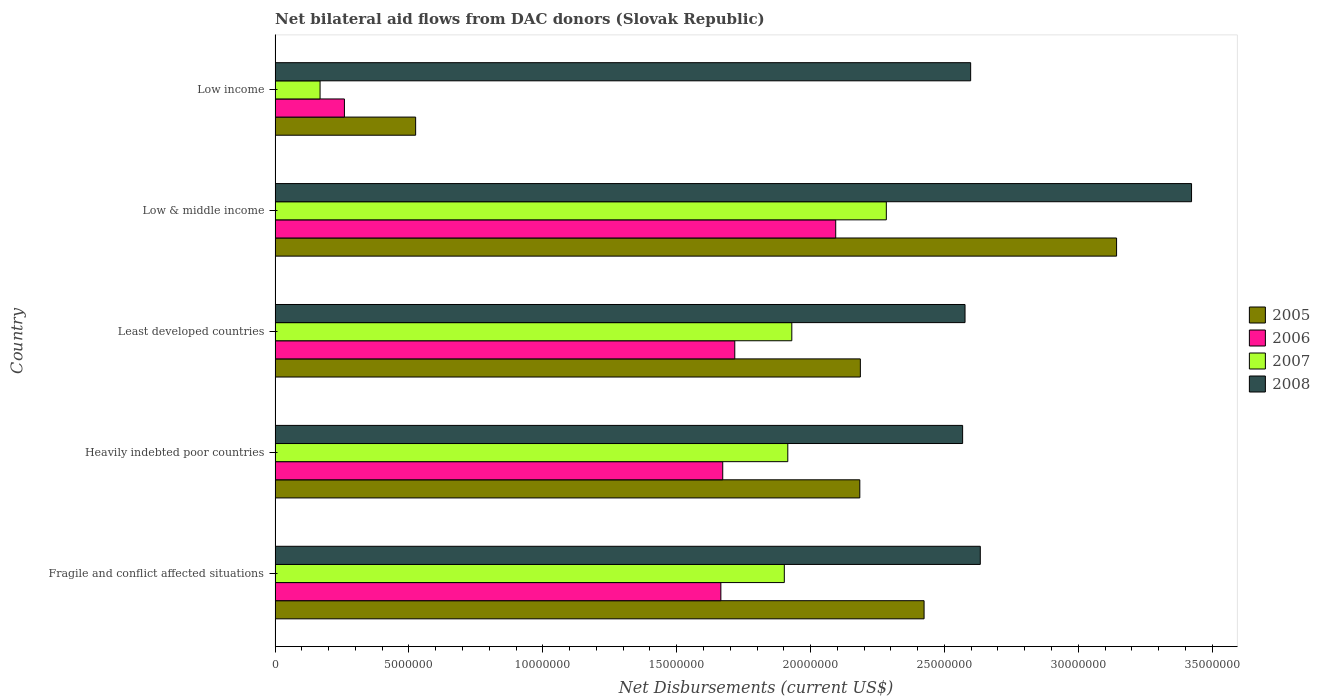How many different coloured bars are there?
Your answer should be very brief. 4. How many groups of bars are there?
Ensure brevity in your answer.  5. How many bars are there on the 3rd tick from the top?
Give a very brief answer. 4. What is the label of the 4th group of bars from the top?
Make the answer very short. Heavily indebted poor countries. What is the net bilateral aid flows in 2008 in Fragile and conflict affected situations?
Your answer should be very brief. 2.63e+07. Across all countries, what is the maximum net bilateral aid flows in 2005?
Give a very brief answer. 3.14e+07. Across all countries, what is the minimum net bilateral aid flows in 2006?
Give a very brief answer. 2.59e+06. In which country was the net bilateral aid flows in 2008 minimum?
Give a very brief answer. Heavily indebted poor countries. What is the total net bilateral aid flows in 2006 in the graph?
Offer a very short reply. 7.41e+07. What is the difference between the net bilateral aid flows in 2005 in Low & middle income and that in Low income?
Give a very brief answer. 2.62e+07. What is the difference between the net bilateral aid flows in 2006 in Low income and the net bilateral aid flows in 2005 in Low & middle income?
Offer a terse response. -2.88e+07. What is the average net bilateral aid flows in 2008 per country?
Provide a short and direct response. 2.76e+07. What is the difference between the net bilateral aid flows in 2007 and net bilateral aid flows in 2006 in Heavily indebted poor countries?
Offer a terse response. 2.43e+06. In how many countries, is the net bilateral aid flows in 2007 greater than 29000000 US$?
Provide a succinct answer. 0. What is the ratio of the net bilateral aid flows in 2005 in Fragile and conflict affected situations to that in Least developed countries?
Your answer should be very brief. 1.11. Is the difference between the net bilateral aid flows in 2007 in Fragile and conflict affected situations and Low income greater than the difference between the net bilateral aid flows in 2006 in Fragile and conflict affected situations and Low income?
Your answer should be very brief. Yes. What is the difference between the highest and the second highest net bilateral aid flows in 2008?
Ensure brevity in your answer.  7.89e+06. What is the difference between the highest and the lowest net bilateral aid flows in 2006?
Provide a short and direct response. 1.84e+07. In how many countries, is the net bilateral aid flows in 2005 greater than the average net bilateral aid flows in 2005 taken over all countries?
Keep it short and to the point. 4. Is the sum of the net bilateral aid flows in 2007 in Heavily indebted poor countries and Least developed countries greater than the maximum net bilateral aid flows in 2005 across all countries?
Your response must be concise. Yes. Is it the case that in every country, the sum of the net bilateral aid flows in 2007 and net bilateral aid flows in 2008 is greater than the net bilateral aid flows in 2006?
Offer a terse response. Yes. How many bars are there?
Provide a short and direct response. 20. What is the difference between two consecutive major ticks on the X-axis?
Your response must be concise. 5.00e+06. Are the values on the major ticks of X-axis written in scientific E-notation?
Make the answer very short. No. Does the graph contain any zero values?
Make the answer very short. No. Does the graph contain grids?
Your response must be concise. No. How many legend labels are there?
Your answer should be very brief. 4. How are the legend labels stacked?
Make the answer very short. Vertical. What is the title of the graph?
Keep it short and to the point. Net bilateral aid flows from DAC donors (Slovak Republic). Does "2009" appear as one of the legend labels in the graph?
Ensure brevity in your answer.  No. What is the label or title of the X-axis?
Offer a terse response. Net Disbursements (current US$). What is the label or title of the Y-axis?
Provide a short and direct response. Country. What is the Net Disbursements (current US$) of 2005 in Fragile and conflict affected situations?
Give a very brief answer. 2.42e+07. What is the Net Disbursements (current US$) in 2006 in Fragile and conflict affected situations?
Your answer should be very brief. 1.66e+07. What is the Net Disbursements (current US$) of 2007 in Fragile and conflict affected situations?
Make the answer very short. 1.90e+07. What is the Net Disbursements (current US$) of 2008 in Fragile and conflict affected situations?
Provide a short and direct response. 2.63e+07. What is the Net Disbursements (current US$) in 2005 in Heavily indebted poor countries?
Keep it short and to the point. 2.18e+07. What is the Net Disbursements (current US$) in 2006 in Heavily indebted poor countries?
Ensure brevity in your answer.  1.67e+07. What is the Net Disbursements (current US$) in 2007 in Heavily indebted poor countries?
Make the answer very short. 1.92e+07. What is the Net Disbursements (current US$) of 2008 in Heavily indebted poor countries?
Offer a very short reply. 2.57e+07. What is the Net Disbursements (current US$) of 2005 in Least developed countries?
Offer a terse response. 2.19e+07. What is the Net Disbursements (current US$) of 2006 in Least developed countries?
Keep it short and to the point. 1.72e+07. What is the Net Disbursements (current US$) of 2007 in Least developed countries?
Make the answer very short. 1.93e+07. What is the Net Disbursements (current US$) of 2008 in Least developed countries?
Make the answer very short. 2.58e+07. What is the Net Disbursements (current US$) of 2005 in Low & middle income?
Your answer should be compact. 3.14e+07. What is the Net Disbursements (current US$) of 2006 in Low & middle income?
Offer a terse response. 2.09e+07. What is the Net Disbursements (current US$) in 2007 in Low & middle income?
Keep it short and to the point. 2.28e+07. What is the Net Disbursements (current US$) in 2008 in Low & middle income?
Provide a succinct answer. 3.42e+07. What is the Net Disbursements (current US$) of 2005 in Low income?
Your response must be concise. 5.25e+06. What is the Net Disbursements (current US$) in 2006 in Low income?
Make the answer very short. 2.59e+06. What is the Net Disbursements (current US$) of 2007 in Low income?
Offer a very short reply. 1.68e+06. What is the Net Disbursements (current US$) in 2008 in Low income?
Your answer should be compact. 2.60e+07. Across all countries, what is the maximum Net Disbursements (current US$) of 2005?
Make the answer very short. 3.14e+07. Across all countries, what is the maximum Net Disbursements (current US$) of 2006?
Ensure brevity in your answer.  2.09e+07. Across all countries, what is the maximum Net Disbursements (current US$) in 2007?
Make the answer very short. 2.28e+07. Across all countries, what is the maximum Net Disbursements (current US$) of 2008?
Your answer should be compact. 3.42e+07. Across all countries, what is the minimum Net Disbursements (current US$) in 2005?
Keep it short and to the point. 5.25e+06. Across all countries, what is the minimum Net Disbursements (current US$) of 2006?
Ensure brevity in your answer.  2.59e+06. Across all countries, what is the minimum Net Disbursements (current US$) in 2007?
Provide a succinct answer. 1.68e+06. Across all countries, what is the minimum Net Disbursements (current US$) in 2008?
Give a very brief answer. 2.57e+07. What is the total Net Disbursements (current US$) in 2005 in the graph?
Your answer should be very brief. 1.05e+08. What is the total Net Disbursements (current US$) of 2006 in the graph?
Keep it short and to the point. 7.41e+07. What is the total Net Disbursements (current US$) in 2007 in the graph?
Ensure brevity in your answer.  8.20e+07. What is the total Net Disbursements (current US$) in 2008 in the graph?
Make the answer very short. 1.38e+08. What is the difference between the Net Disbursements (current US$) of 2005 in Fragile and conflict affected situations and that in Heavily indebted poor countries?
Offer a terse response. 2.40e+06. What is the difference between the Net Disbursements (current US$) in 2007 in Fragile and conflict affected situations and that in Heavily indebted poor countries?
Your answer should be very brief. -1.30e+05. What is the difference between the Net Disbursements (current US$) in 2005 in Fragile and conflict affected situations and that in Least developed countries?
Give a very brief answer. 2.38e+06. What is the difference between the Net Disbursements (current US$) in 2006 in Fragile and conflict affected situations and that in Least developed countries?
Keep it short and to the point. -5.20e+05. What is the difference between the Net Disbursements (current US$) of 2007 in Fragile and conflict affected situations and that in Least developed countries?
Make the answer very short. -2.80e+05. What is the difference between the Net Disbursements (current US$) in 2008 in Fragile and conflict affected situations and that in Least developed countries?
Offer a very short reply. 5.70e+05. What is the difference between the Net Disbursements (current US$) in 2005 in Fragile and conflict affected situations and that in Low & middle income?
Your response must be concise. -7.19e+06. What is the difference between the Net Disbursements (current US$) of 2006 in Fragile and conflict affected situations and that in Low & middle income?
Ensure brevity in your answer.  -4.29e+06. What is the difference between the Net Disbursements (current US$) of 2007 in Fragile and conflict affected situations and that in Low & middle income?
Keep it short and to the point. -3.81e+06. What is the difference between the Net Disbursements (current US$) in 2008 in Fragile and conflict affected situations and that in Low & middle income?
Offer a very short reply. -7.89e+06. What is the difference between the Net Disbursements (current US$) of 2005 in Fragile and conflict affected situations and that in Low income?
Offer a terse response. 1.90e+07. What is the difference between the Net Disbursements (current US$) of 2006 in Fragile and conflict affected situations and that in Low income?
Your response must be concise. 1.41e+07. What is the difference between the Net Disbursements (current US$) of 2007 in Fragile and conflict affected situations and that in Low income?
Your answer should be very brief. 1.73e+07. What is the difference between the Net Disbursements (current US$) of 2008 in Fragile and conflict affected situations and that in Low income?
Make the answer very short. 3.60e+05. What is the difference between the Net Disbursements (current US$) of 2006 in Heavily indebted poor countries and that in Least developed countries?
Give a very brief answer. -4.50e+05. What is the difference between the Net Disbursements (current US$) in 2005 in Heavily indebted poor countries and that in Low & middle income?
Your answer should be very brief. -9.59e+06. What is the difference between the Net Disbursements (current US$) in 2006 in Heavily indebted poor countries and that in Low & middle income?
Ensure brevity in your answer.  -4.22e+06. What is the difference between the Net Disbursements (current US$) of 2007 in Heavily indebted poor countries and that in Low & middle income?
Your response must be concise. -3.68e+06. What is the difference between the Net Disbursements (current US$) in 2008 in Heavily indebted poor countries and that in Low & middle income?
Offer a very short reply. -8.55e+06. What is the difference between the Net Disbursements (current US$) in 2005 in Heavily indebted poor countries and that in Low income?
Your answer should be very brief. 1.66e+07. What is the difference between the Net Disbursements (current US$) in 2006 in Heavily indebted poor countries and that in Low income?
Ensure brevity in your answer.  1.41e+07. What is the difference between the Net Disbursements (current US$) in 2007 in Heavily indebted poor countries and that in Low income?
Offer a terse response. 1.75e+07. What is the difference between the Net Disbursements (current US$) in 2005 in Least developed countries and that in Low & middle income?
Ensure brevity in your answer.  -9.57e+06. What is the difference between the Net Disbursements (current US$) in 2006 in Least developed countries and that in Low & middle income?
Offer a very short reply. -3.77e+06. What is the difference between the Net Disbursements (current US$) in 2007 in Least developed countries and that in Low & middle income?
Keep it short and to the point. -3.53e+06. What is the difference between the Net Disbursements (current US$) of 2008 in Least developed countries and that in Low & middle income?
Make the answer very short. -8.46e+06. What is the difference between the Net Disbursements (current US$) in 2005 in Least developed countries and that in Low income?
Keep it short and to the point. 1.66e+07. What is the difference between the Net Disbursements (current US$) of 2006 in Least developed countries and that in Low income?
Ensure brevity in your answer.  1.46e+07. What is the difference between the Net Disbursements (current US$) of 2007 in Least developed countries and that in Low income?
Provide a succinct answer. 1.76e+07. What is the difference between the Net Disbursements (current US$) in 2005 in Low & middle income and that in Low income?
Offer a terse response. 2.62e+07. What is the difference between the Net Disbursements (current US$) in 2006 in Low & middle income and that in Low income?
Your response must be concise. 1.84e+07. What is the difference between the Net Disbursements (current US$) of 2007 in Low & middle income and that in Low income?
Your answer should be compact. 2.12e+07. What is the difference between the Net Disbursements (current US$) in 2008 in Low & middle income and that in Low income?
Provide a succinct answer. 8.25e+06. What is the difference between the Net Disbursements (current US$) in 2005 in Fragile and conflict affected situations and the Net Disbursements (current US$) in 2006 in Heavily indebted poor countries?
Your response must be concise. 7.52e+06. What is the difference between the Net Disbursements (current US$) in 2005 in Fragile and conflict affected situations and the Net Disbursements (current US$) in 2007 in Heavily indebted poor countries?
Give a very brief answer. 5.09e+06. What is the difference between the Net Disbursements (current US$) of 2005 in Fragile and conflict affected situations and the Net Disbursements (current US$) of 2008 in Heavily indebted poor countries?
Offer a very short reply. -1.44e+06. What is the difference between the Net Disbursements (current US$) of 2006 in Fragile and conflict affected situations and the Net Disbursements (current US$) of 2007 in Heavily indebted poor countries?
Make the answer very short. -2.50e+06. What is the difference between the Net Disbursements (current US$) in 2006 in Fragile and conflict affected situations and the Net Disbursements (current US$) in 2008 in Heavily indebted poor countries?
Ensure brevity in your answer.  -9.03e+06. What is the difference between the Net Disbursements (current US$) in 2007 in Fragile and conflict affected situations and the Net Disbursements (current US$) in 2008 in Heavily indebted poor countries?
Offer a terse response. -6.66e+06. What is the difference between the Net Disbursements (current US$) in 2005 in Fragile and conflict affected situations and the Net Disbursements (current US$) in 2006 in Least developed countries?
Offer a terse response. 7.07e+06. What is the difference between the Net Disbursements (current US$) of 2005 in Fragile and conflict affected situations and the Net Disbursements (current US$) of 2007 in Least developed countries?
Provide a succinct answer. 4.94e+06. What is the difference between the Net Disbursements (current US$) in 2005 in Fragile and conflict affected situations and the Net Disbursements (current US$) in 2008 in Least developed countries?
Your answer should be very brief. -1.53e+06. What is the difference between the Net Disbursements (current US$) of 2006 in Fragile and conflict affected situations and the Net Disbursements (current US$) of 2007 in Least developed countries?
Offer a very short reply. -2.65e+06. What is the difference between the Net Disbursements (current US$) of 2006 in Fragile and conflict affected situations and the Net Disbursements (current US$) of 2008 in Least developed countries?
Provide a succinct answer. -9.12e+06. What is the difference between the Net Disbursements (current US$) in 2007 in Fragile and conflict affected situations and the Net Disbursements (current US$) in 2008 in Least developed countries?
Your response must be concise. -6.75e+06. What is the difference between the Net Disbursements (current US$) in 2005 in Fragile and conflict affected situations and the Net Disbursements (current US$) in 2006 in Low & middle income?
Your response must be concise. 3.30e+06. What is the difference between the Net Disbursements (current US$) in 2005 in Fragile and conflict affected situations and the Net Disbursements (current US$) in 2007 in Low & middle income?
Ensure brevity in your answer.  1.41e+06. What is the difference between the Net Disbursements (current US$) of 2005 in Fragile and conflict affected situations and the Net Disbursements (current US$) of 2008 in Low & middle income?
Offer a terse response. -9.99e+06. What is the difference between the Net Disbursements (current US$) in 2006 in Fragile and conflict affected situations and the Net Disbursements (current US$) in 2007 in Low & middle income?
Give a very brief answer. -6.18e+06. What is the difference between the Net Disbursements (current US$) in 2006 in Fragile and conflict affected situations and the Net Disbursements (current US$) in 2008 in Low & middle income?
Make the answer very short. -1.76e+07. What is the difference between the Net Disbursements (current US$) of 2007 in Fragile and conflict affected situations and the Net Disbursements (current US$) of 2008 in Low & middle income?
Provide a succinct answer. -1.52e+07. What is the difference between the Net Disbursements (current US$) of 2005 in Fragile and conflict affected situations and the Net Disbursements (current US$) of 2006 in Low income?
Give a very brief answer. 2.16e+07. What is the difference between the Net Disbursements (current US$) of 2005 in Fragile and conflict affected situations and the Net Disbursements (current US$) of 2007 in Low income?
Offer a very short reply. 2.26e+07. What is the difference between the Net Disbursements (current US$) in 2005 in Fragile and conflict affected situations and the Net Disbursements (current US$) in 2008 in Low income?
Ensure brevity in your answer.  -1.74e+06. What is the difference between the Net Disbursements (current US$) of 2006 in Fragile and conflict affected situations and the Net Disbursements (current US$) of 2007 in Low income?
Your answer should be very brief. 1.50e+07. What is the difference between the Net Disbursements (current US$) in 2006 in Fragile and conflict affected situations and the Net Disbursements (current US$) in 2008 in Low income?
Make the answer very short. -9.33e+06. What is the difference between the Net Disbursements (current US$) of 2007 in Fragile and conflict affected situations and the Net Disbursements (current US$) of 2008 in Low income?
Ensure brevity in your answer.  -6.96e+06. What is the difference between the Net Disbursements (current US$) in 2005 in Heavily indebted poor countries and the Net Disbursements (current US$) in 2006 in Least developed countries?
Your response must be concise. 4.67e+06. What is the difference between the Net Disbursements (current US$) of 2005 in Heavily indebted poor countries and the Net Disbursements (current US$) of 2007 in Least developed countries?
Your answer should be compact. 2.54e+06. What is the difference between the Net Disbursements (current US$) of 2005 in Heavily indebted poor countries and the Net Disbursements (current US$) of 2008 in Least developed countries?
Your answer should be compact. -3.93e+06. What is the difference between the Net Disbursements (current US$) of 2006 in Heavily indebted poor countries and the Net Disbursements (current US$) of 2007 in Least developed countries?
Make the answer very short. -2.58e+06. What is the difference between the Net Disbursements (current US$) of 2006 in Heavily indebted poor countries and the Net Disbursements (current US$) of 2008 in Least developed countries?
Offer a terse response. -9.05e+06. What is the difference between the Net Disbursements (current US$) of 2007 in Heavily indebted poor countries and the Net Disbursements (current US$) of 2008 in Least developed countries?
Provide a short and direct response. -6.62e+06. What is the difference between the Net Disbursements (current US$) in 2005 in Heavily indebted poor countries and the Net Disbursements (current US$) in 2007 in Low & middle income?
Your answer should be compact. -9.90e+05. What is the difference between the Net Disbursements (current US$) in 2005 in Heavily indebted poor countries and the Net Disbursements (current US$) in 2008 in Low & middle income?
Your answer should be very brief. -1.24e+07. What is the difference between the Net Disbursements (current US$) of 2006 in Heavily indebted poor countries and the Net Disbursements (current US$) of 2007 in Low & middle income?
Your answer should be very brief. -6.11e+06. What is the difference between the Net Disbursements (current US$) in 2006 in Heavily indebted poor countries and the Net Disbursements (current US$) in 2008 in Low & middle income?
Keep it short and to the point. -1.75e+07. What is the difference between the Net Disbursements (current US$) of 2007 in Heavily indebted poor countries and the Net Disbursements (current US$) of 2008 in Low & middle income?
Provide a succinct answer. -1.51e+07. What is the difference between the Net Disbursements (current US$) of 2005 in Heavily indebted poor countries and the Net Disbursements (current US$) of 2006 in Low income?
Keep it short and to the point. 1.92e+07. What is the difference between the Net Disbursements (current US$) in 2005 in Heavily indebted poor countries and the Net Disbursements (current US$) in 2007 in Low income?
Your answer should be very brief. 2.02e+07. What is the difference between the Net Disbursements (current US$) of 2005 in Heavily indebted poor countries and the Net Disbursements (current US$) of 2008 in Low income?
Provide a succinct answer. -4.14e+06. What is the difference between the Net Disbursements (current US$) in 2006 in Heavily indebted poor countries and the Net Disbursements (current US$) in 2007 in Low income?
Your response must be concise. 1.50e+07. What is the difference between the Net Disbursements (current US$) in 2006 in Heavily indebted poor countries and the Net Disbursements (current US$) in 2008 in Low income?
Make the answer very short. -9.26e+06. What is the difference between the Net Disbursements (current US$) in 2007 in Heavily indebted poor countries and the Net Disbursements (current US$) in 2008 in Low income?
Your answer should be compact. -6.83e+06. What is the difference between the Net Disbursements (current US$) of 2005 in Least developed countries and the Net Disbursements (current US$) of 2006 in Low & middle income?
Provide a succinct answer. 9.20e+05. What is the difference between the Net Disbursements (current US$) of 2005 in Least developed countries and the Net Disbursements (current US$) of 2007 in Low & middle income?
Your answer should be very brief. -9.70e+05. What is the difference between the Net Disbursements (current US$) in 2005 in Least developed countries and the Net Disbursements (current US$) in 2008 in Low & middle income?
Keep it short and to the point. -1.24e+07. What is the difference between the Net Disbursements (current US$) of 2006 in Least developed countries and the Net Disbursements (current US$) of 2007 in Low & middle income?
Your answer should be compact. -5.66e+06. What is the difference between the Net Disbursements (current US$) in 2006 in Least developed countries and the Net Disbursements (current US$) in 2008 in Low & middle income?
Make the answer very short. -1.71e+07. What is the difference between the Net Disbursements (current US$) in 2007 in Least developed countries and the Net Disbursements (current US$) in 2008 in Low & middle income?
Make the answer very short. -1.49e+07. What is the difference between the Net Disbursements (current US$) in 2005 in Least developed countries and the Net Disbursements (current US$) in 2006 in Low income?
Make the answer very short. 1.93e+07. What is the difference between the Net Disbursements (current US$) of 2005 in Least developed countries and the Net Disbursements (current US$) of 2007 in Low income?
Your answer should be very brief. 2.02e+07. What is the difference between the Net Disbursements (current US$) in 2005 in Least developed countries and the Net Disbursements (current US$) in 2008 in Low income?
Your response must be concise. -4.12e+06. What is the difference between the Net Disbursements (current US$) of 2006 in Least developed countries and the Net Disbursements (current US$) of 2007 in Low income?
Give a very brief answer. 1.55e+07. What is the difference between the Net Disbursements (current US$) in 2006 in Least developed countries and the Net Disbursements (current US$) in 2008 in Low income?
Your response must be concise. -8.81e+06. What is the difference between the Net Disbursements (current US$) of 2007 in Least developed countries and the Net Disbursements (current US$) of 2008 in Low income?
Offer a very short reply. -6.68e+06. What is the difference between the Net Disbursements (current US$) of 2005 in Low & middle income and the Net Disbursements (current US$) of 2006 in Low income?
Keep it short and to the point. 2.88e+07. What is the difference between the Net Disbursements (current US$) in 2005 in Low & middle income and the Net Disbursements (current US$) in 2007 in Low income?
Keep it short and to the point. 2.98e+07. What is the difference between the Net Disbursements (current US$) of 2005 in Low & middle income and the Net Disbursements (current US$) of 2008 in Low income?
Ensure brevity in your answer.  5.45e+06. What is the difference between the Net Disbursements (current US$) in 2006 in Low & middle income and the Net Disbursements (current US$) in 2007 in Low income?
Offer a terse response. 1.93e+07. What is the difference between the Net Disbursements (current US$) of 2006 in Low & middle income and the Net Disbursements (current US$) of 2008 in Low income?
Offer a very short reply. -5.04e+06. What is the difference between the Net Disbursements (current US$) in 2007 in Low & middle income and the Net Disbursements (current US$) in 2008 in Low income?
Your response must be concise. -3.15e+06. What is the average Net Disbursements (current US$) in 2005 per country?
Ensure brevity in your answer.  2.09e+07. What is the average Net Disbursements (current US$) of 2006 per country?
Ensure brevity in your answer.  1.48e+07. What is the average Net Disbursements (current US$) of 2007 per country?
Offer a terse response. 1.64e+07. What is the average Net Disbursements (current US$) of 2008 per country?
Your answer should be compact. 2.76e+07. What is the difference between the Net Disbursements (current US$) in 2005 and Net Disbursements (current US$) in 2006 in Fragile and conflict affected situations?
Give a very brief answer. 7.59e+06. What is the difference between the Net Disbursements (current US$) in 2005 and Net Disbursements (current US$) in 2007 in Fragile and conflict affected situations?
Make the answer very short. 5.22e+06. What is the difference between the Net Disbursements (current US$) in 2005 and Net Disbursements (current US$) in 2008 in Fragile and conflict affected situations?
Provide a short and direct response. -2.10e+06. What is the difference between the Net Disbursements (current US$) in 2006 and Net Disbursements (current US$) in 2007 in Fragile and conflict affected situations?
Your answer should be very brief. -2.37e+06. What is the difference between the Net Disbursements (current US$) of 2006 and Net Disbursements (current US$) of 2008 in Fragile and conflict affected situations?
Ensure brevity in your answer.  -9.69e+06. What is the difference between the Net Disbursements (current US$) of 2007 and Net Disbursements (current US$) of 2008 in Fragile and conflict affected situations?
Make the answer very short. -7.32e+06. What is the difference between the Net Disbursements (current US$) in 2005 and Net Disbursements (current US$) in 2006 in Heavily indebted poor countries?
Provide a short and direct response. 5.12e+06. What is the difference between the Net Disbursements (current US$) in 2005 and Net Disbursements (current US$) in 2007 in Heavily indebted poor countries?
Offer a terse response. 2.69e+06. What is the difference between the Net Disbursements (current US$) of 2005 and Net Disbursements (current US$) of 2008 in Heavily indebted poor countries?
Make the answer very short. -3.84e+06. What is the difference between the Net Disbursements (current US$) in 2006 and Net Disbursements (current US$) in 2007 in Heavily indebted poor countries?
Offer a very short reply. -2.43e+06. What is the difference between the Net Disbursements (current US$) in 2006 and Net Disbursements (current US$) in 2008 in Heavily indebted poor countries?
Your answer should be very brief. -8.96e+06. What is the difference between the Net Disbursements (current US$) of 2007 and Net Disbursements (current US$) of 2008 in Heavily indebted poor countries?
Your answer should be compact. -6.53e+06. What is the difference between the Net Disbursements (current US$) of 2005 and Net Disbursements (current US$) of 2006 in Least developed countries?
Offer a terse response. 4.69e+06. What is the difference between the Net Disbursements (current US$) in 2005 and Net Disbursements (current US$) in 2007 in Least developed countries?
Offer a terse response. 2.56e+06. What is the difference between the Net Disbursements (current US$) in 2005 and Net Disbursements (current US$) in 2008 in Least developed countries?
Offer a very short reply. -3.91e+06. What is the difference between the Net Disbursements (current US$) in 2006 and Net Disbursements (current US$) in 2007 in Least developed countries?
Ensure brevity in your answer.  -2.13e+06. What is the difference between the Net Disbursements (current US$) of 2006 and Net Disbursements (current US$) of 2008 in Least developed countries?
Ensure brevity in your answer.  -8.60e+06. What is the difference between the Net Disbursements (current US$) in 2007 and Net Disbursements (current US$) in 2008 in Least developed countries?
Provide a succinct answer. -6.47e+06. What is the difference between the Net Disbursements (current US$) of 2005 and Net Disbursements (current US$) of 2006 in Low & middle income?
Give a very brief answer. 1.05e+07. What is the difference between the Net Disbursements (current US$) in 2005 and Net Disbursements (current US$) in 2007 in Low & middle income?
Your response must be concise. 8.60e+06. What is the difference between the Net Disbursements (current US$) in 2005 and Net Disbursements (current US$) in 2008 in Low & middle income?
Offer a very short reply. -2.80e+06. What is the difference between the Net Disbursements (current US$) of 2006 and Net Disbursements (current US$) of 2007 in Low & middle income?
Your answer should be compact. -1.89e+06. What is the difference between the Net Disbursements (current US$) of 2006 and Net Disbursements (current US$) of 2008 in Low & middle income?
Provide a short and direct response. -1.33e+07. What is the difference between the Net Disbursements (current US$) of 2007 and Net Disbursements (current US$) of 2008 in Low & middle income?
Provide a short and direct response. -1.14e+07. What is the difference between the Net Disbursements (current US$) of 2005 and Net Disbursements (current US$) of 2006 in Low income?
Your answer should be compact. 2.66e+06. What is the difference between the Net Disbursements (current US$) in 2005 and Net Disbursements (current US$) in 2007 in Low income?
Your answer should be compact. 3.57e+06. What is the difference between the Net Disbursements (current US$) of 2005 and Net Disbursements (current US$) of 2008 in Low income?
Your answer should be compact. -2.07e+07. What is the difference between the Net Disbursements (current US$) in 2006 and Net Disbursements (current US$) in 2007 in Low income?
Offer a terse response. 9.10e+05. What is the difference between the Net Disbursements (current US$) of 2006 and Net Disbursements (current US$) of 2008 in Low income?
Your response must be concise. -2.34e+07. What is the difference between the Net Disbursements (current US$) in 2007 and Net Disbursements (current US$) in 2008 in Low income?
Your answer should be very brief. -2.43e+07. What is the ratio of the Net Disbursements (current US$) of 2005 in Fragile and conflict affected situations to that in Heavily indebted poor countries?
Provide a succinct answer. 1.11. What is the ratio of the Net Disbursements (current US$) of 2006 in Fragile and conflict affected situations to that in Heavily indebted poor countries?
Offer a very short reply. 1. What is the ratio of the Net Disbursements (current US$) of 2007 in Fragile and conflict affected situations to that in Heavily indebted poor countries?
Give a very brief answer. 0.99. What is the ratio of the Net Disbursements (current US$) of 2008 in Fragile and conflict affected situations to that in Heavily indebted poor countries?
Ensure brevity in your answer.  1.03. What is the ratio of the Net Disbursements (current US$) of 2005 in Fragile and conflict affected situations to that in Least developed countries?
Your answer should be very brief. 1.11. What is the ratio of the Net Disbursements (current US$) of 2006 in Fragile and conflict affected situations to that in Least developed countries?
Give a very brief answer. 0.97. What is the ratio of the Net Disbursements (current US$) of 2007 in Fragile and conflict affected situations to that in Least developed countries?
Provide a short and direct response. 0.99. What is the ratio of the Net Disbursements (current US$) of 2008 in Fragile and conflict affected situations to that in Least developed countries?
Your response must be concise. 1.02. What is the ratio of the Net Disbursements (current US$) of 2005 in Fragile and conflict affected situations to that in Low & middle income?
Your response must be concise. 0.77. What is the ratio of the Net Disbursements (current US$) in 2006 in Fragile and conflict affected situations to that in Low & middle income?
Ensure brevity in your answer.  0.8. What is the ratio of the Net Disbursements (current US$) of 2007 in Fragile and conflict affected situations to that in Low & middle income?
Keep it short and to the point. 0.83. What is the ratio of the Net Disbursements (current US$) of 2008 in Fragile and conflict affected situations to that in Low & middle income?
Make the answer very short. 0.77. What is the ratio of the Net Disbursements (current US$) of 2005 in Fragile and conflict affected situations to that in Low income?
Your answer should be compact. 4.62. What is the ratio of the Net Disbursements (current US$) of 2006 in Fragile and conflict affected situations to that in Low income?
Offer a very short reply. 6.43. What is the ratio of the Net Disbursements (current US$) of 2007 in Fragile and conflict affected situations to that in Low income?
Provide a short and direct response. 11.32. What is the ratio of the Net Disbursements (current US$) of 2008 in Fragile and conflict affected situations to that in Low income?
Ensure brevity in your answer.  1.01. What is the ratio of the Net Disbursements (current US$) in 2006 in Heavily indebted poor countries to that in Least developed countries?
Provide a short and direct response. 0.97. What is the ratio of the Net Disbursements (current US$) in 2008 in Heavily indebted poor countries to that in Least developed countries?
Your response must be concise. 1. What is the ratio of the Net Disbursements (current US$) in 2005 in Heavily indebted poor countries to that in Low & middle income?
Your response must be concise. 0.69. What is the ratio of the Net Disbursements (current US$) of 2006 in Heavily indebted poor countries to that in Low & middle income?
Ensure brevity in your answer.  0.8. What is the ratio of the Net Disbursements (current US$) of 2007 in Heavily indebted poor countries to that in Low & middle income?
Keep it short and to the point. 0.84. What is the ratio of the Net Disbursements (current US$) of 2008 in Heavily indebted poor countries to that in Low & middle income?
Provide a succinct answer. 0.75. What is the ratio of the Net Disbursements (current US$) in 2005 in Heavily indebted poor countries to that in Low income?
Ensure brevity in your answer.  4.16. What is the ratio of the Net Disbursements (current US$) in 2006 in Heavily indebted poor countries to that in Low income?
Your answer should be very brief. 6.46. What is the ratio of the Net Disbursements (current US$) in 2007 in Heavily indebted poor countries to that in Low income?
Offer a terse response. 11.4. What is the ratio of the Net Disbursements (current US$) in 2005 in Least developed countries to that in Low & middle income?
Your answer should be very brief. 0.7. What is the ratio of the Net Disbursements (current US$) of 2006 in Least developed countries to that in Low & middle income?
Your response must be concise. 0.82. What is the ratio of the Net Disbursements (current US$) in 2007 in Least developed countries to that in Low & middle income?
Provide a succinct answer. 0.85. What is the ratio of the Net Disbursements (current US$) in 2008 in Least developed countries to that in Low & middle income?
Give a very brief answer. 0.75. What is the ratio of the Net Disbursements (current US$) of 2005 in Least developed countries to that in Low income?
Offer a terse response. 4.16. What is the ratio of the Net Disbursements (current US$) in 2006 in Least developed countries to that in Low income?
Provide a short and direct response. 6.63. What is the ratio of the Net Disbursements (current US$) in 2007 in Least developed countries to that in Low income?
Keep it short and to the point. 11.49. What is the ratio of the Net Disbursements (current US$) in 2008 in Least developed countries to that in Low income?
Provide a succinct answer. 0.99. What is the ratio of the Net Disbursements (current US$) of 2005 in Low & middle income to that in Low income?
Offer a very short reply. 5.99. What is the ratio of the Net Disbursements (current US$) in 2006 in Low & middle income to that in Low income?
Give a very brief answer. 8.08. What is the ratio of the Net Disbursements (current US$) of 2007 in Low & middle income to that in Low income?
Provide a short and direct response. 13.59. What is the ratio of the Net Disbursements (current US$) in 2008 in Low & middle income to that in Low income?
Your response must be concise. 1.32. What is the difference between the highest and the second highest Net Disbursements (current US$) of 2005?
Your answer should be very brief. 7.19e+06. What is the difference between the highest and the second highest Net Disbursements (current US$) in 2006?
Ensure brevity in your answer.  3.77e+06. What is the difference between the highest and the second highest Net Disbursements (current US$) of 2007?
Ensure brevity in your answer.  3.53e+06. What is the difference between the highest and the second highest Net Disbursements (current US$) of 2008?
Provide a short and direct response. 7.89e+06. What is the difference between the highest and the lowest Net Disbursements (current US$) in 2005?
Ensure brevity in your answer.  2.62e+07. What is the difference between the highest and the lowest Net Disbursements (current US$) of 2006?
Your answer should be compact. 1.84e+07. What is the difference between the highest and the lowest Net Disbursements (current US$) in 2007?
Give a very brief answer. 2.12e+07. What is the difference between the highest and the lowest Net Disbursements (current US$) of 2008?
Offer a very short reply. 8.55e+06. 